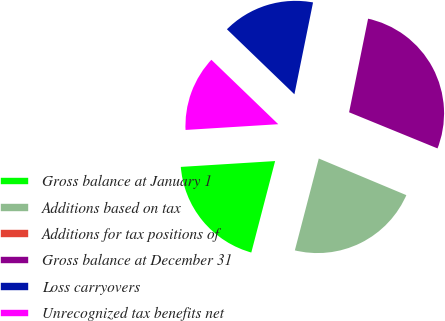Convert chart. <chart><loc_0><loc_0><loc_500><loc_500><pie_chart><fcel>Gross balance at January 1<fcel>Additions based on tax<fcel>Additions for tax positions of<fcel>Gross balance at December 31<fcel>Loss carryovers<fcel>Unrecognized tax benefits net<nl><fcel>19.96%<fcel>22.75%<fcel>0.13%<fcel>27.99%<fcel>15.98%<fcel>13.19%<nl></chart> 